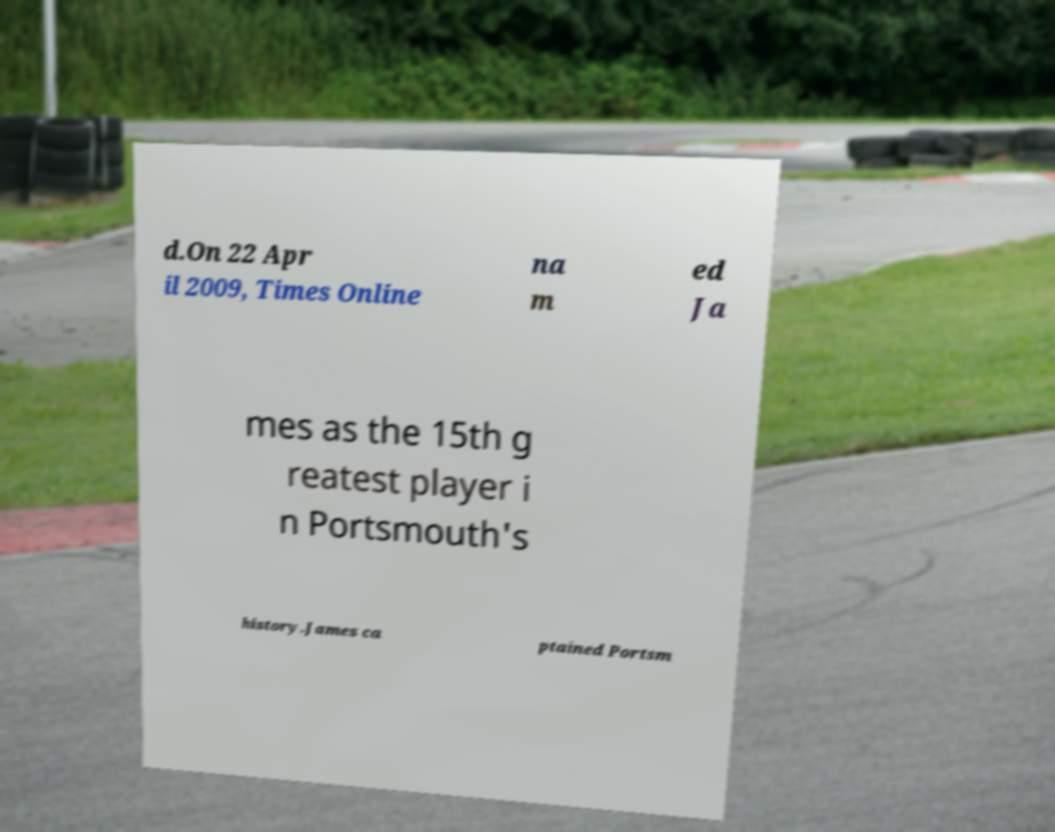Can you accurately transcribe the text from the provided image for me? d.On 22 Apr il 2009, Times Online na m ed Ja mes as the 15th g reatest player i n Portsmouth's history.James ca ptained Portsm 